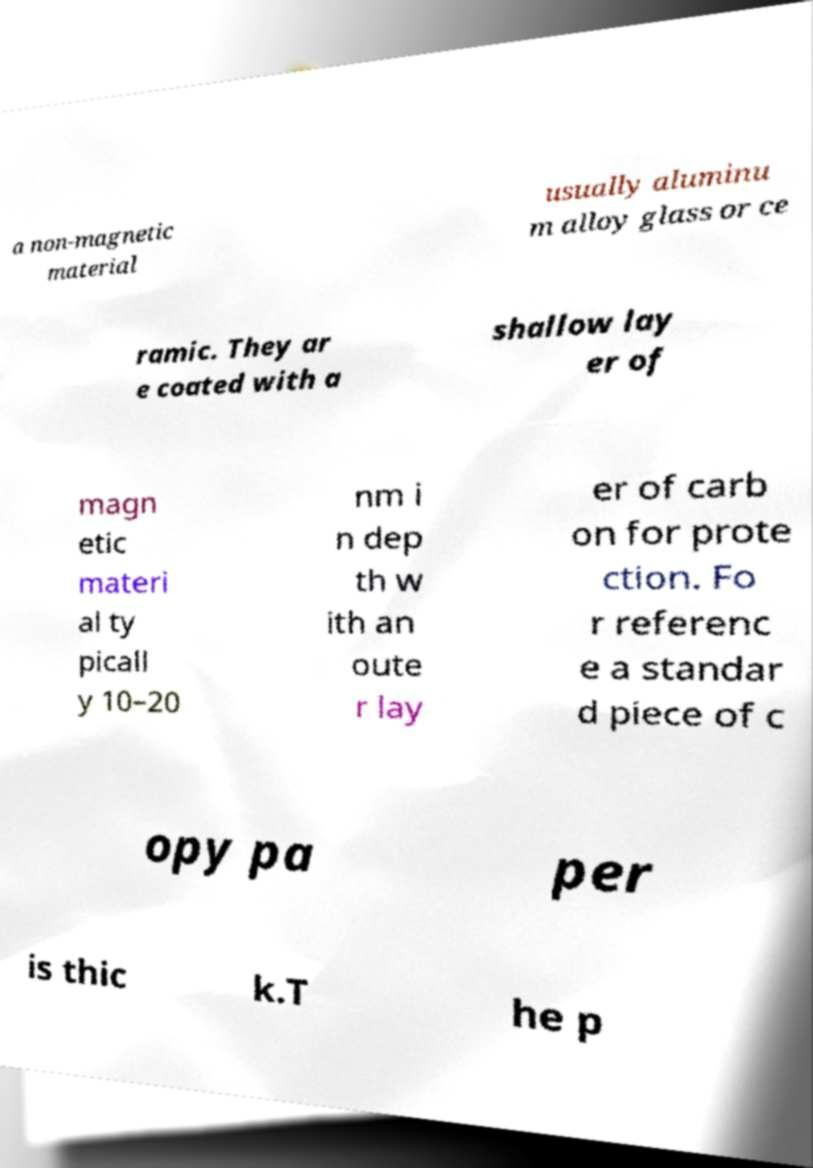What messages or text are displayed in this image? I need them in a readable, typed format. a non-magnetic material usually aluminu m alloy glass or ce ramic. They ar e coated with a shallow lay er of magn etic materi al ty picall y 10–20 nm i n dep th w ith an oute r lay er of carb on for prote ction. Fo r referenc e a standar d piece of c opy pa per is thic k.T he p 